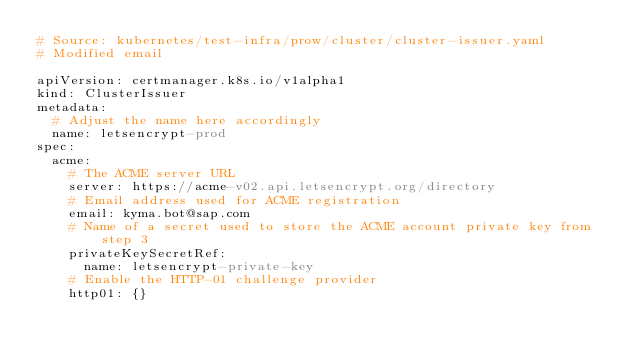<code> <loc_0><loc_0><loc_500><loc_500><_YAML_># Source: kubernetes/test-infra/prow/cluster/cluster-issuer.yaml
# Modified email

apiVersion: certmanager.k8s.io/v1alpha1
kind: ClusterIssuer
metadata:
  # Adjust the name here accordingly
  name: letsencrypt-prod
spec:
  acme:
    # The ACME server URL
    server: https://acme-v02.api.letsencrypt.org/directory
    # Email address used for ACME registration
    email: kyma.bot@sap.com
    # Name of a secret used to store the ACME account private key from step 3
    privateKeySecretRef:
      name: letsencrypt-private-key
    # Enable the HTTP-01 challenge provider
    http01: {}
</code> 